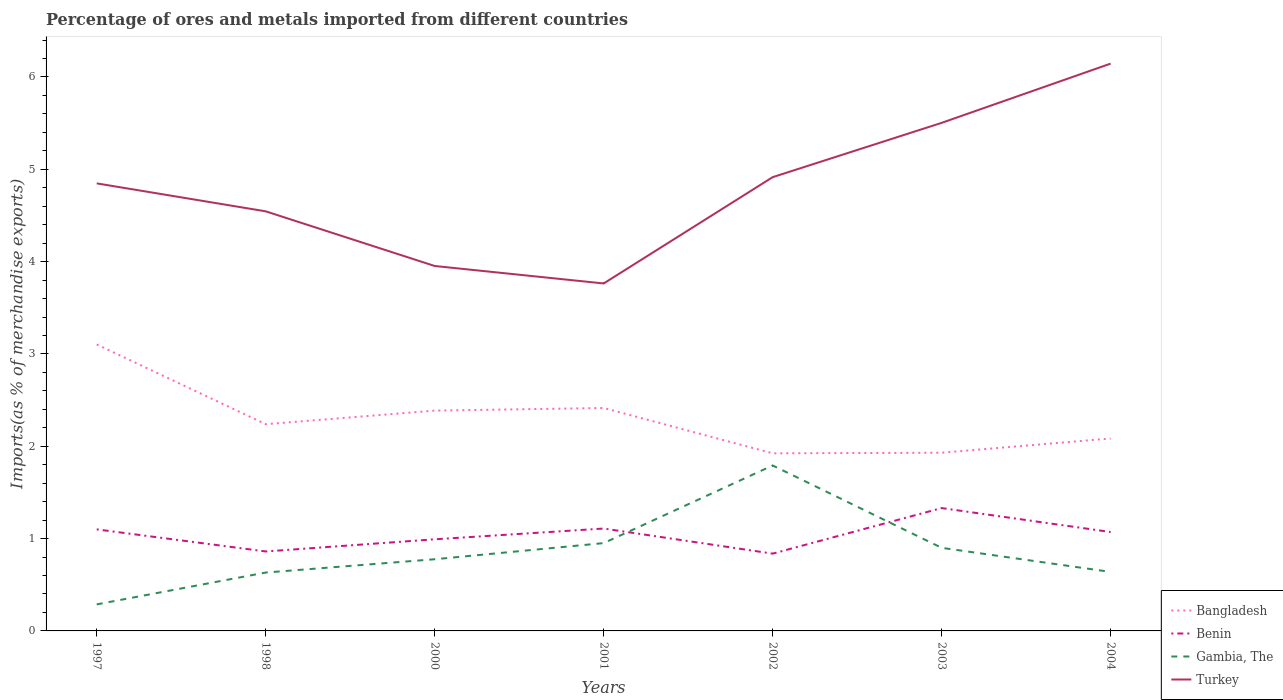Does the line corresponding to Bangladesh intersect with the line corresponding to Turkey?
Offer a terse response. No. Is the number of lines equal to the number of legend labels?
Your answer should be very brief. Yes. Across all years, what is the maximum percentage of imports to different countries in Benin?
Your response must be concise. 0.84. In which year was the percentage of imports to different countries in Gambia, The maximum?
Offer a terse response. 1997. What is the total percentage of imports to different countries in Turkey in the graph?
Make the answer very short. 0.89. What is the difference between the highest and the second highest percentage of imports to different countries in Benin?
Your response must be concise. 0.49. Does the graph contain grids?
Provide a succinct answer. No. How many legend labels are there?
Your response must be concise. 4. What is the title of the graph?
Provide a succinct answer. Percentage of ores and metals imported from different countries. Does "Kenya" appear as one of the legend labels in the graph?
Your answer should be very brief. No. What is the label or title of the Y-axis?
Your answer should be compact. Imports(as % of merchandise exports). What is the Imports(as % of merchandise exports) in Bangladesh in 1997?
Offer a very short reply. 3.1. What is the Imports(as % of merchandise exports) in Benin in 1997?
Offer a very short reply. 1.1. What is the Imports(as % of merchandise exports) in Gambia, The in 1997?
Offer a very short reply. 0.29. What is the Imports(as % of merchandise exports) of Turkey in 1997?
Give a very brief answer. 4.85. What is the Imports(as % of merchandise exports) of Bangladesh in 1998?
Your answer should be compact. 2.24. What is the Imports(as % of merchandise exports) of Benin in 1998?
Keep it short and to the point. 0.86. What is the Imports(as % of merchandise exports) in Gambia, The in 1998?
Give a very brief answer. 0.63. What is the Imports(as % of merchandise exports) of Turkey in 1998?
Your response must be concise. 4.54. What is the Imports(as % of merchandise exports) of Bangladesh in 2000?
Your answer should be compact. 2.39. What is the Imports(as % of merchandise exports) of Benin in 2000?
Make the answer very short. 0.99. What is the Imports(as % of merchandise exports) in Gambia, The in 2000?
Provide a succinct answer. 0.78. What is the Imports(as % of merchandise exports) in Turkey in 2000?
Your answer should be compact. 3.95. What is the Imports(as % of merchandise exports) of Bangladesh in 2001?
Provide a succinct answer. 2.41. What is the Imports(as % of merchandise exports) of Benin in 2001?
Make the answer very short. 1.11. What is the Imports(as % of merchandise exports) in Gambia, The in 2001?
Ensure brevity in your answer.  0.95. What is the Imports(as % of merchandise exports) of Turkey in 2001?
Offer a very short reply. 3.76. What is the Imports(as % of merchandise exports) in Bangladesh in 2002?
Keep it short and to the point. 1.92. What is the Imports(as % of merchandise exports) in Benin in 2002?
Provide a succinct answer. 0.84. What is the Imports(as % of merchandise exports) in Gambia, The in 2002?
Keep it short and to the point. 1.79. What is the Imports(as % of merchandise exports) in Turkey in 2002?
Give a very brief answer. 4.91. What is the Imports(as % of merchandise exports) in Bangladesh in 2003?
Offer a terse response. 1.93. What is the Imports(as % of merchandise exports) in Benin in 2003?
Keep it short and to the point. 1.33. What is the Imports(as % of merchandise exports) in Gambia, The in 2003?
Give a very brief answer. 0.9. What is the Imports(as % of merchandise exports) of Turkey in 2003?
Your answer should be compact. 5.5. What is the Imports(as % of merchandise exports) in Bangladesh in 2004?
Provide a succinct answer. 2.08. What is the Imports(as % of merchandise exports) in Benin in 2004?
Your answer should be compact. 1.07. What is the Imports(as % of merchandise exports) of Gambia, The in 2004?
Your answer should be compact. 0.64. What is the Imports(as % of merchandise exports) of Turkey in 2004?
Your answer should be very brief. 6.14. Across all years, what is the maximum Imports(as % of merchandise exports) of Bangladesh?
Provide a short and direct response. 3.1. Across all years, what is the maximum Imports(as % of merchandise exports) of Benin?
Your answer should be very brief. 1.33. Across all years, what is the maximum Imports(as % of merchandise exports) of Gambia, The?
Provide a short and direct response. 1.79. Across all years, what is the maximum Imports(as % of merchandise exports) in Turkey?
Keep it short and to the point. 6.14. Across all years, what is the minimum Imports(as % of merchandise exports) of Bangladesh?
Provide a succinct answer. 1.92. Across all years, what is the minimum Imports(as % of merchandise exports) in Benin?
Ensure brevity in your answer.  0.84. Across all years, what is the minimum Imports(as % of merchandise exports) of Gambia, The?
Provide a short and direct response. 0.29. Across all years, what is the minimum Imports(as % of merchandise exports) of Turkey?
Keep it short and to the point. 3.76. What is the total Imports(as % of merchandise exports) in Bangladesh in the graph?
Your answer should be compact. 16.08. What is the total Imports(as % of merchandise exports) of Benin in the graph?
Make the answer very short. 7.3. What is the total Imports(as % of merchandise exports) of Gambia, The in the graph?
Make the answer very short. 5.98. What is the total Imports(as % of merchandise exports) of Turkey in the graph?
Your answer should be very brief. 33.67. What is the difference between the Imports(as % of merchandise exports) in Bangladesh in 1997 and that in 1998?
Your response must be concise. 0.86. What is the difference between the Imports(as % of merchandise exports) of Benin in 1997 and that in 1998?
Give a very brief answer. 0.24. What is the difference between the Imports(as % of merchandise exports) in Gambia, The in 1997 and that in 1998?
Offer a terse response. -0.34. What is the difference between the Imports(as % of merchandise exports) of Turkey in 1997 and that in 1998?
Your response must be concise. 0.3. What is the difference between the Imports(as % of merchandise exports) of Bangladesh in 1997 and that in 2000?
Make the answer very short. 0.72. What is the difference between the Imports(as % of merchandise exports) of Benin in 1997 and that in 2000?
Your answer should be compact. 0.11. What is the difference between the Imports(as % of merchandise exports) in Gambia, The in 1997 and that in 2000?
Offer a very short reply. -0.49. What is the difference between the Imports(as % of merchandise exports) of Turkey in 1997 and that in 2000?
Make the answer very short. 0.89. What is the difference between the Imports(as % of merchandise exports) in Bangladesh in 1997 and that in 2001?
Your answer should be compact. 0.69. What is the difference between the Imports(as % of merchandise exports) in Benin in 1997 and that in 2001?
Provide a short and direct response. -0.01. What is the difference between the Imports(as % of merchandise exports) in Gambia, The in 1997 and that in 2001?
Ensure brevity in your answer.  -0.66. What is the difference between the Imports(as % of merchandise exports) in Turkey in 1997 and that in 2001?
Ensure brevity in your answer.  1.08. What is the difference between the Imports(as % of merchandise exports) of Bangladesh in 1997 and that in 2002?
Offer a very short reply. 1.18. What is the difference between the Imports(as % of merchandise exports) of Benin in 1997 and that in 2002?
Give a very brief answer. 0.26. What is the difference between the Imports(as % of merchandise exports) in Gambia, The in 1997 and that in 2002?
Your response must be concise. -1.5. What is the difference between the Imports(as % of merchandise exports) in Turkey in 1997 and that in 2002?
Offer a very short reply. -0.07. What is the difference between the Imports(as % of merchandise exports) in Bangladesh in 1997 and that in 2003?
Provide a short and direct response. 1.17. What is the difference between the Imports(as % of merchandise exports) of Benin in 1997 and that in 2003?
Ensure brevity in your answer.  -0.23. What is the difference between the Imports(as % of merchandise exports) of Gambia, The in 1997 and that in 2003?
Make the answer very short. -0.61. What is the difference between the Imports(as % of merchandise exports) of Turkey in 1997 and that in 2003?
Your response must be concise. -0.66. What is the difference between the Imports(as % of merchandise exports) of Bangladesh in 1997 and that in 2004?
Make the answer very short. 1.02. What is the difference between the Imports(as % of merchandise exports) of Benin in 1997 and that in 2004?
Offer a terse response. 0.03. What is the difference between the Imports(as % of merchandise exports) in Gambia, The in 1997 and that in 2004?
Ensure brevity in your answer.  -0.35. What is the difference between the Imports(as % of merchandise exports) of Turkey in 1997 and that in 2004?
Keep it short and to the point. -1.3. What is the difference between the Imports(as % of merchandise exports) in Bangladesh in 1998 and that in 2000?
Your answer should be very brief. -0.15. What is the difference between the Imports(as % of merchandise exports) of Benin in 1998 and that in 2000?
Provide a succinct answer. -0.13. What is the difference between the Imports(as % of merchandise exports) in Gambia, The in 1998 and that in 2000?
Offer a terse response. -0.14. What is the difference between the Imports(as % of merchandise exports) of Turkey in 1998 and that in 2000?
Your answer should be very brief. 0.59. What is the difference between the Imports(as % of merchandise exports) of Bangladesh in 1998 and that in 2001?
Provide a short and direct response. -0.18. What is the difference between the Imports(as % of merchandise exports) of Benin in 1998 and that in 2001?
Offer a terse response. -0.25. What is the difference between the Imports(as % of merchandise exports) in Gambia, The in 1998 and that in 2001?
Ensure brevity in your answer.  -0.32. What is the difference between the Imports(as % of merchandise exports) of Turkey in 1998 and that in 2001?
Ensure brevity in your answer.  0.78. What is the difference between the Imports(as % of merchandise exports) in Bangladesh in 1998 and that in 2002?
Your response must be concise. 0.32. What is the difference between the Imports(as % of merchandise exports) of Benin in 1998 and that in 2002?
Offer a very short reply. 0.02. What is the difference between the Imports(as % of merchandise exports) in Gambia, The in 1998 and that in 2002?
Make the answer very short. -1.16. What is the difference between the Imports(as % of merchandise exports) of Turkey in 1998 and that in 2002?
Your answer should be very brief. -0.37. What is the difference between the Imports(as % of merchandise exports) in Bangladesh in 1998 and that in 2003?
Give a very brief answer. 0.31. What is the difference between the Imports(as % of merchandise exports) of Benin in 1998 and that in 2003?
Offer a very short reply. -0.47. What is the difference between the Imports(as % of merchandise exports) of Gambia, The in 1998 and that in 2003?
Your response must be concise. -0.27. What is the difference between the Imports(as % of merchandise exports) of Turkey in 1998 and that in 2003?
Provide a short and direct response. -0.96. What is the difference between the Imports(as % of merchandise exports) of Bangladesh in 1998 and that in 2004?
Offer a very short reply. 0.15. What is the difference between the Imports(as % of merchandise exports) of Benin in 1998 and that in 2004?
Provide a short and direct response. -0.21. What is the difference between the Imports(as % of merchandise exports) of Gambia, The in 1998 and that in 2004?
Provide a succinct answer. -0.01. What is the difference between the Imports(as % of merchandise exports) of Turkey in 1998 and that in 2004?
Provide a succinct answer. -1.6. What is the difference between the Imports(as % of merchandise exports) of Bangladesh in 2000 and that in 2001?
Your response must be concise. -0.03. What is the difference between the Imports(as % of merchandise exports) in Benin in 2000 and that in 2001?
Your response must be concise. -0.12. What is the difference between the Imports(as % of merchandise exports) in Gambia, The in 2000 and that in 2001?
Offer a terse response. -0.17. What is the difference between the Imports(as % of merchandise exports) in Turkey in 2000 and that in 2001?
Your answer should be very brief. 0.19. What is the difference between the Imports(as % of merchandise exports) in Bangladesh in 2000 and that in 2002?
Ensure brevity in your answer.  0.46. What is the difference between the Imports(as % of merchandise exports) of Benin in 2000 and that in 2002?
Provide a succinct answer. 0.16. What is the difference between the Imports(as % of merchandise exports) of Gambia, The in 2000 and that in 2002?
Provide a succinct answer. -1.02. What is the difference between the Imports(as % of merchandise exports) of Turkey in 2000 and that in 2002?
Your response must be concise. -0.96. What is the difference between the Imports(as % of merchandise exports) of Bangladesh in 2000 and that in 2003?
Keep it short and to the point. 0.46. What is the difference between the Imports(as % of merchandise exports) in Benin in 2000 and that in 2003?
Your answer should be very brief. -0.34. What is the difference between the Imports(as % of merchandise exports) in Gambia, The in 2000 and that in 2003?
Make the answer very short. -0.12. What is the difference between the Imports(as % of merchandise exports) of Turkey in 2000 and that in 2003?
Provide a succinct answer. -1.55. What is the difference between the Imports(as % of merchandise exports) in Bangladesh in 2000 and that in 2004?
Your answer should be compact. 0.3. What is the difference between the Imports(as % of merchandise exports) of Benin in 2000 and that in 2004?
Give a very brief answer. -0.08. What is the difference between the Imports(as % of merchandise exports) of Gambia, The in 2000 and that in 2004?
Your answer should be compact. 0.14. What is the difference between the Imports(as % of merchandise exports) in Turkey in 2000 and that in 2004?
Your response must be concise. -2.19. What is the difference between the Imports(as % of merchandise exports) in Bangladesh in 2001 and that in 2002?
Provide a succinct answer. 0.49. What is the difference between the Imports(as % of merchandise exports) of Benin in 2001 and that in 2002?
Your response must be concise. 0.27. What is the difference between the Imports(as % of merchandise exports) in Gambia, The in 2001 and that in 2002?
Offer a very short reply. -0.84. What is the difference between the Imports(as % of merchandise exports) in Turkey in 2001 and that in 2002?
Keep it short and to the point. -1.15. What is the difference between the Imports(as % of merchandise exports) in Bangladesh in 2001 and that in 2003?
Your response must be concise. 0.48. What is the difference between the Imports(as % of merchandise exports) of Benin in 2001 and that in 2003?
Provide a short and direct response. -0.22. What is the difference between the Imports(as % of merchandise exports) of Gambia, The in 2001 and that in 2003?
Provide a short and direct response. 0.05. What is the difference between the Imports(as % of merchandise exports) of Turkey in 2001 and that in 2003?
Your response must be concise. -1.74. What is the difference between the Imports(as % of merchandise exports) of Bangladesh in 2001 and that in 2004?
Ensure brevity in your answer.  0.33. What is the difference between the Imports(as % of merchandise exports) in Benin in 2001 and that in 2004?
Provide a short and direct response. 0.04. What is the difference between the Imports(as % of merchandise exports) in Gambia, The in 2001 and that in 2004?
Ensure brevity in your answer.  0.31. What is the difference between the Imports(as % of merchandise exports) of Turkey in 2001 and that in 2004?
Your response must be concise. -2.38. What is the difference between the Imports(as % of merchandise exports) of Bangladesh in 2002 and that in 2003?
Your response must be concise. -0.01. What is the difference between the Imports(as % of merchandise exports) in Benin in 2002 and that in 2003?
Ensure brevity in your answer.  -0.49. What is the difference between the Imports(as % of merchandise exports) of Gambia, The in 2002 and that in 2003?
Your answer should be compact. 0.89. What is the difference between the Imports(as % of merchandise exports) of Turkey in 2002 and that in 2003?
Your answer should be compact. -0.59. What is the difference between the Imports(as % of merchandise exports) of Bangladesh in 2002 and that in 2004?
Provide a succinct answer. -0.16. What is the difference between the Imports(as % of merchandise exports) in Benin in 2002 and that in 2004?
Offer a very short reply. -0.23. What is the difference between the Imports(as % of merchandise exports) of Gambia, The in 2002 and that in 2004?
Make the answer very short. 1.15. What is the difference between the Imports(as % of merchandise exports) of Turkey in 2002 and that in 2004?
Your answer should be very brief. -1.23. What is the difference between the Imports(as % of merchandise exports) in Bangladesh in 2003 and that in 2004?
Offer a very short reply. -0.15. What is the difference between the Imports(as % of merchandise exports) in Benin in 2003 and that in 2004?
Make the answer very short. 0.26. What is the difference between the Imports(as % of merchandise exports) of Gambia, The in 2003 and that in 2004?
Offer a terse response. 0.26. What is the difference between the Imports(as % of merchandise exports) of Turkey in 2003 and that in 2004?
Offer a terse response. -0.64. What is the difference between the Imports(as % of merchandise exports) of Bangladesh in 1997 and the Imports(as % of merchandise exports) of Benin in 1998?
Provide a short and direct response. 2.24. What is the difference between the Imports(as % of merchandise exports) in Bangladesh in 1997 and the Imports(as % of merchandise exports) in Gambia, The in 1998?
Your response must be concise. 2.47. What is the difference between the Imports(as % of merchandise exports) of Bangladesh in 1997 and the Imports(as % of merchandise exports) of Turkey in 1998?
Your response must be concise. -1.44. What is the difference between the Imports(as % of merchandise exports) in Benin in 1997 and the Imports(as % of merchandise exports) in Gambia, The in 1998?
Provide a succinct answer. 0.47. What is the difference between the Imports(as % of merchandise exports) of Benin in 1997 and the Imports(as % of merchandise exports) of Turkey in 1998?
Offer a very short reply. -3.44. What is the difference between the Imports(as % of merchandise exports) in Gambia, The in 1997 and the Imports(as % of merchandise exports) in Turkey in 1998?
Your response must be concise. -4.26. What is the difference between the Imports(as % of merchandise exports) of Bangladesh in 1997 and the Imports(as % of merchandise exports) of Benin in 2000?
Give a very brief answer. 2.11. What is the difference between the Imports(as % of merchandise exports) in Bangladesh in 1997 and the Imports(as % of merchandise exports) in Gambia, The in 2000?
Keep it short and to the point. 2.33. What is the difference between the Imports(as % of merchandise exports) in Bangladesh in 1997 and the Imports(as % of merchandise exports) in Turkey in 2000?
Keep it short and to the point. -0.85. What is the difference between the Imports(as % of merchandise exports) in Benin in 1997 and the Imports(as % of merchandise exports) in Gambia, The in 2000?
Provide a succinct answer. 0.32. What is the difference between the Imports(as % of merchandise exports) of Benin in 1997 and the Imports(as % of merchandise exports) of Turkey in 2000?
Make the answer very short. -2.85. What is the difference between the Imports(as % of merchandise exports) of Gambia, The in 1997 and the Imports(as % of merchandise exports) of Turkey in 2000?
Give a very brief answer. -3.67. What is the difference between the Imports(as % of merchandise exports) of Bangladesh in 1997 and the Imports(as % of merchandise exports) of Benin in 2001?
Keep it short and to the point. 1.99. What is the difference between the Imports(as % of merchandise exports) in Bangladesh in 1997 and the Imports(as % of merchandise exports) in Gambia, The in 2001?
Provide a short and direct response. 2.15. What is the difference between the Imports(as % of merchandise exports) in Bangladesh in 1997 and the Imports(as % of merchandise exports) in Turkey in 2001?
Ensure brevity in your answer.  -0.66. What is the difference between the Imports(as % of merchandise exports) in Benin in 1997 and the Imports(as % of merchandise exports) in Gambia, The in 2001?
Your response must be concise. 0.15. What is the difference between the Imports(as % of merchandise exports) of Benin in 1997 and the Imports(as % of merchandise exports) of Turkey in 2001?
Provide a succinct answer. -2.66. What is the difference between the Imports(as % of merchandise exports) in Gambia, The in 1997 and the Imports(as % of merchandise exports) in Turkey in 2001?
Your answer should be compact. -3.48. What is the difference between the Imports(as % of merchandise exports) in Bangladesh in 1997 and the Imports(as % of merchandise exports) in Benin in 2002?
Offer a very short reply. 2.27. What is the difference between the Imports(as % of merchandise exports) of Bangladesh in 1997 and the Imports(as % of merchandise exports) of Gambia, The in 2002?
Your response must be concise. 1.31. What is the difference between the Imports(as % of merchandise exports) in Bangladesh in 1997 and the Imports(as % of merchandise exports) in Turkey in 2002?
Offer a very short reply. -1.81. What is the difference between the Imports(as % of merchandise exports) in Benin in 1997 and the Imports(as % of merchandise exports) in Gambia, The in 2002?
Make the answer very short. -0.69. What is the difference between the Imports(as % of merchandise exports) in Benin in 1997 and the Imports(as % of merchandise exports) in Turkey in 2002?
Provide a short and direct response. -3.81. What is the difference between the Imports(as % of merchandise exports) of Gambia, The in 1997 and the Imports(as % of merchandise exports) of Turkey in 2002?
Offer a very short reply. -4.63. What is the difference between the Imports(as % of merchandise exports) in Bangladesh in 1997 and the Imports(as % of merchandise exports) in Benin in 2003?
Ensure brevity in your answer.  1.77. What is the difference between the Imports(as % of merchandise exports) of Bangladesh in 1997 and the Imports(as % of merchandise exports) of Gambia, The in 2003?
Offer a very short reply. 2.2. What is the difference between the Imports(as % of merchandise exports) in Bangladesh in 1997 and the Imports(as % of merchandise exports) in Turkey in 2003?
Your answer should be compact. -2.4. What is the difference between the Imports(as % of merchandise exports) in Benin in 1997 and the Imports(as % of merchandise exports) in Gambia, The in 2003?
Your answer should be compact. 0.2. What is the difference between the Imports(as % of merchandise exports) in Benin in 1997 and the Imports(as % of merchandise exports) in Turkey in 2003?
Give a very brief answer. -4.4. What is the difference between the Imports(as % of merchandise exports) in Gambia, The in 1997 and the Imports(as % of merchandise exports) in Turkey in 2003?
Ensure brevity in your answer.  -5.22. What is the difference between the Imports(as % of merchandise exports) of Bangladesh in 1997 and the Imports(as % of merchandise exports) of Benin in 2004?
Offer a very short reply. 2.03. What is the difference between the Imports(as % of merchandise exports) in Bangladesh in 1997 and the Imports(as % of merchandise exports) in Gambia, The in 2004?
Provide a short and direct response. 2.46. What is the difference between the Imports(as % of merchandise exports) in Bangladesh in 1997 and the Imports(as % of merchandise exports) in Turkey in 2004?
Your answer should be very brief. -3.04. What is the difference between the Imports(as % of merchandise exports) in Benin in 1997 and the Imports(as % of merchandise exports) in Gambia, The in 2004?
Ensure brevity in your answer.  0.46. What is the difference between the Imports(as % of merchandise exports) of Benin in 1997 and the Imports(as % of merchandise exports) of Turkey in 2004?
Ensure brevity in your answer.  -5.04. What is the difference between the Imports(as % of merchandise exports) in Gambia, The in 1997 and the Imports(as % of merchandise exports) in Turkey in 2004?
Provide a short and direct response. -5.86. What is the difference between the Imports(as % of merchandise exports) of Bangladesh in 1998 and the Imports(as % of merchandise exports) of Benin in 2000?
Your answer should be compact. 1.25. What is the difference between the Imports(as % of merchandise exports) of Bangladesh in 1998 and the Imports(as % of merchandise exports) of Gambia, The in 2000?
Offer a very short reply. 1.46. What is the difference between the Imports(as % of merchandise exports) of Bangladesh in 1998 and the Imports(as % of merchandise exports) of Turkey in 2000?
Keep it short and to the point. -1.71. What is the difference between the Imports(as % of merchandise exports) in Benin in 1998 and the Imports(as % of merchandise exports) in Gambia, The in 2000?
Your response must be concise. 0.08. What is the difference between the Imports(as % of merchandise exports) in Benin in 1998 and the Imports(as % of merchandise exports) in Turkey in 2000?
Your answer should be very brief. -3.09. What is the difference between the Imports(as % of merchandise exports) of Gambia, The in 1998 and the Imports(as % of merchandise exports) of Turkey in 2000?
Make the answer very short. -3.32. What is the difference between the Imports(as % of merchandise exports) in Bangladesh in 1998 and the Imports(as % of merchandise exports) in Benin in 2001?
Make the answer very short. 1.13. What is the difference between the Imports(as % of merchandise exports) of Bangladesh in 1998 and the Imports(as % of merchandise exports) of Gambia, The in 2001?
Keep it short and to the point. 1.29. What is the difference between the Imports(as % of merchandise exports) in Bangladesh in 1998 and the Imports(as % of merchandise exports) in Turkey in 2001?
Provide a short and direct response. -1.52. What is the difference between the Imports(as % of merchandise exports) in Benin in 1998 and the Imports(as % of merchandise exports) in Gambia, The in 2001?
Offer a very short reply. -0.09. What is the difference between the Imports(as % of merchandise exports) in Benin in 1998 and the Imports(as % of merchandise exports) in Turkey in 2001?
Offer a terse response. -2.9. What is the difference between the Imports(as % of merchandise exports) of Gambia, The in 1998 and the Imports(as % of merchandise exports) of Turkey in 2001?
Offer a terse response. -3.13. What is the difference between the Imports(as % of merchandise exports) in Bangladesh in 1998 and the Imports(as % of merchandise exports) in Benin in 2002?
Ensure brevity in your answer.  1.4. What is the difference between the Imports(as % of merchandise exports) of Bangladesh in 1998 and the Imports(as % of merchandise exports) of Gambia, The in 2002?
Make the answer very short. 0.45. What is the difference between the Imports(as % of merchandise exports) in Bangladesh in 1998 and the Imports(as % of merchandise exports) in Turkey in 2002?
Offer a terse response. -2.68. What is the difference between the Imports(as % of merchandise exports) in Benin in 1998 and the Imports(as % of merchandise exports) in Gambia, The in 2002?
Ensure brevity in your answer.  -0.93. What is the difference between the Imports(as % of merchandise exports) in Benin in 1998 and the Imports(as % of merchandise exports) in Turkey in 2002?
Provide a succinct answer. -4.05. What is the difference between the Imports(as % of merchandise exports) of Gambia, The in 1998 and the Imports(as % of merchandise exports) of Turkey in 2002?
Give a very brief answer. -4.28. What is the difference between the Imports(as % of merchandise exports) of Bangladesh in 1998 and the Imports(as % of merchandise exports) of Benin in 2003?
Provide a succinct answer. 0.91. What is the difference between the Imports(as % of merchandise exports) in Bangladesh in 1998 and the Imports(as % of merchandise exports) in Gambia, The in 2003?
Provide a succinct answer. 1.34. What is the difference between the Imports(as % of merchandise exports) of Bangladesh in 1998 and the Imports(as % of merchandise exports) of Turkey in 2003?
Give a very brief answer. -3.26. What is the difference between the Imports(as % of merchandise exports) of Benin in 1998 and the Imports(as % of merchandise exports) of Gambia, The in 2003?
Your answer should be compact. -0.04. What is the difference between the Imports(as % of merchandise exports) in Benin in 1998 and the Imports(as % of merchandise exports) in Turkey in 2003?
Keep it short and to the point. -4.64. What is the difference between the Imports(as % of merchandise exports) in Gambia, The in 1998 and the Imports(as % of merchandise exports) in Turkey in 2003?
Provide a succinct answer. -4.87. What is the difference between the Imports(as % of merchandise exports) of Bangladesh in 1998 and the Imports(as % of merchandise exports) of Benin in 2004?
Make the answer very short. 1.17. What is the difference between the Imports(as % of merchandise exports) of Bangladesh in 1998 and the Imports(as % of merchandise exports) of Gambia, The in 2004?
Your answer should be compact. 1.6. What is the difference between the Imports(as % of merchandise exports) of Bangladesh in 1998 and the Imports(as % of merchandise exports) of Turkey in 2004?
Your answer should be very brief. -3.91. What is the difference between the Imports(as % of merchandise exports) of Benin in 1998 and the Imports(as % of merchandise exports) of Gambia, The in 2004?
Your answer should be compact. 0.22. What is the difference between the Imports(as % of merchandise exports) of Benin in 1998 and the Imports(as % of merchandise exports) of Turkey in 2004?
Your answer should be very brief. -5.28. What is the difference between the Imports(as % of merchandise exports) in Gambia, The in 1998 and the Imports(as % of merchandise exports) in Turkey in 2004?
Your response must be concise. -5.51. What is the difference between the Imports(as % of merchandise exports) in Bangladesh in 2000 and the Imports(as % of merchandise exports) in Benin in 2001?
Your response must be concise. 1.28. What is the difference between the Imports(as % of merchandise exports) in Bangladesh in 2000 and the Imports(as % of merchandise exports) in Gambia, The in 2001?
Make the answer very short. 1.44. What is the difference between the Imports(as % of merchandise exports) in Bangladesh in 2000 and the Imports(as % of merchandise exports) in Turkey in 2001?
Offer a terse response. -1.38. What is the difference between the Imports(as % of merchandise exports) of Benin in 2000 and the Imports(as % of merchandise exports) of Gambia, The in 2001?
Give a very brief answer. 0.04. What is the difference between the Imports(as % of merchandise exports) in Benin in 2000 and the Imports(as % of merchandise exports) in Turkey in 2001?
Provide a succinct answer. -2.77. What is the difference between the Imports(as % of merchandise exports) of Gambia, The in 2000 and the Imports(as % of merchandise exports) of Turkey in 2001?
Your answer should be compact. -2.99. What is the difference between the Imports(as % of merchandise exports) in Bangladesh in 2000 and the Imports(as % of merchandise exports) in Benin in 2002?
Your response must be concise. 1.55. What is the difference between the Imports(as % of merchandise exports) in Bangladesh in 2000 and the Imports(as % of merchandise exports) in Gambia, The in 2002?
Make the answer very short. 0.59. What is the difference between the Imports(as % of merchandise exports) of Bangladesh in 2000 and the Imports(as % of merchandise exports) of Turkey in 2002?
Provide a short and direct response. -2.53. What is the difference between the Imports(as % of merchandise exports) in Benin in 2000 and the Imports(as % of merchandise exports) in Gambia, The in 2002?
Offer a very short reply. -0.8. What is the difference between the Imports(as % of merchandise exports) in Benin in 2000 and the Imports(as % of merchandise exports) in Turkey in 2002?
Your answer should be very brief. -3.92. What is the difference between the Imports(as % of merchandise exports) of Gambia, The in 2000 and the Imports(as % of merchandise exports) of Turkey in 2002?
Your response must be concise. -4.14. What is the difference between the Imports(as % of merchandise exports) of Bangladesh in 2000 and the Imports(as % of merchandise exports) of Benin in 2003?
Offer a very short reply. 1.06. What is the difference between the Imports(as % of merchandise exports) of Bangladesh in 2000 and the Imports(as % of merchandise exports) of Gambia, The in 2003?
Your answer should be very brief. 1.49. What is the difference between the Imports(as % of merchandise exports) of Bangladesh in 2000 and the Imports(as % of merchandise exports) of Turkey in 2003?
Offer a very short reply. -3.12. What is the difference between the Imports(as % of merchandise exports) in Benin in 2000 and the Imports(as % of merchandise exports) in Gambia, The in 2003?
Offer a terse response. 0.09. What is the difference between the Imports(as % of merchandise exports) of Benin in 2000 and the Imports(as % of merchandise exports) of Turkey in 2003?
Offer a terse response. -4.51. What is the difference between the Imports(as % of merchandise exports) in Gambia, The in 2000 and the Imports(as % of merchandise exports) in Turkey in 2003?
Your answer should be very brief. -4.73. What is the difference between the Imports(as % of merchandise exports) in Bangladesh in 2000 and the Imports(as % of merchandise exports) in Benin in 2004?
Keep it short and to the point. 1.32. What is the difference between the Imports(as % of merchandise exports) in Bangladesh in 2000 and the Imports(as % of merchandise exports) in Gambia, The in 2004?
Offer a very short reply. 1.75. What is the difference between the Imports(as % of merchandise exports) in Bangladesh in 2000 and the Imports(as % of merchandise exports) in Turkey in 2004?
Give a very brief answer. -3.76. What is the difference between the Imports(as % of merchandise exports) of Benin in 2000 and the Imports(as % of merchandise exports) of Gambia, The in 2004?
Ensure brevity in your answer.  0.35. What is the difference between the Imports(as % of merchandise exports) in Benin in 2000 and the Imports(as % of merchandise exports) in Turkey in 2004?
Ensure brevity in your answer.  -5.15. What is the difference between the Imports(as % of merchandise exports) in Gambia, The in 2000 and the Imports(as % of merchandise exports) in Turkey in 2004?
Your answer should be very brief. -5.37. What is the difference between the Imports(as % of merchandise exports) in Bangladesh in 2001 and the Imports(as % of merchandise exports) in Benin in 2002?
Offer a terse response. 1.58. What is the difference between the Imports(as % of merchandise exports) of Bangladesh in 2001 and the Imports(as % of merchandise exports) of Gambia, The in 2002?
Offer a very short reply. 0.62. What is the difference between the Imports(as % of merchandise exports) in Bangladesh in 2001 and the Imports(as % of merchandise exports) in Turkey in 2002?
Keep it short and to the point. -2.5. What is the difference between the Imports(as % of merchandise exports) of Benin in 2001 and the Imports(as % of merchandise exports) of Gambia, The in 2002?
Ensure brevity in your answer.  -0.68. What is the difference between the Imports(as % of merchandise exports) of Benin in 2001 and the Imports(as % of merchandise exports) of Turkey in 2002?
Keep it short and to the point. -3.81. What is the difference between the Imports(as % of merchandise exports) of Gambia, The in 2001 and the Imports(as % of merchandise exports) of Turkey in 2002?
Give a very brief answer. -3.96. What is the difference between the Imports(as % of merchandise exports) in Bangladesh in 2001 and the Imports(as % of merchandise exports) in Benin in 2003?
Give a very brief answer. 1.08. What is the difference between the Imports(as % of merchandise exports) in Bangladesh in 2001 and the Imports(as % of merchandise exports) in Gambia, The in 2003?
Your response must be concise. 1.51. What is the difference between the Imports(as % of merchandise exports) of Bangladesh in 2001 and the Imports(as % of merchandise exports) of Turkey in 2003?
Keep it short and to the point. -3.09. What is the difference between the Imports(as % of merchandise exports) of Benin in 2001 and the Imports(as % of merchandise exports) of Gambia, The in 2003?
Ensure brevity in your answer.  0.21. What is the difference between the Imports(as % of merchandise exports) of Benin in 2001 and the Imports(as % of merchandise exports) of Turkey in 2003?
Your answer should be very brief. -4.39. What is the difference between the Imports(as % of merchandise exports) of Gambia, The in 2001 and the Imports(as % of merchandise exports) of Turkey in 2003?
Provide a succinct answer. -4.55. What is the difference between the Imports(as % of merchandise exports) in Bangladesh in 2001 and the Imports(as % of merchandise exports) in Benin in 2004?
Your answer should be compact. 1.34. What is the difference between the Imports(as % of merchandise exports) in Bangladesh in 2001 and the Imports(as % of merchandise exports) in Gambia, The in 2004?
Provide a short and direct response. 1.78. What is the difference between the Imports(as % of merchandise exports) of Bangladesh in 2001 and the Imports(as % of merchandise exports) of Turkey in 2004?
Your answer should be compact. -3.73. What is the difference between the Imports(as % of merchandise exports) in Benin in 2001 and the Imports(as % of merchandise exports) in Gambia, The in 2004?
Ensure brevity in your answer.  0.47. What is the difference between the Imports(as % of merchandise exports) of Benin in 2001 and the Imports(as % of merchandise exports) of Turkey in 2004?
Offer a terse response. -5.04. What is the difference between the Imports(as % of merchandise exports) in Gambia, The in 2001 and the Imports(as % of merchandise exports) in Turkey in 2004?
Offer a terse response. -5.19. What is the difference between the Imports(as % of merchandise exports) of Bangladesh in 2002 and the Imports(as % of merchandise exports) of Benin in 2003?
Give a very brief answer. 0.59. What is the difference between the Imports(as % of merchandise exports) in Bangladesh in 2002 and the Imports(as % of merchandise exports) in Gambia, The in 2003?
Provide a succinct answer. 1.02. What is the difference between the Imports(as % of merchandise exports) in Bangladesh in 2002 and the Imports(as % of merchandise exports) in Turkey in 2003?
Provide a succinct answer. -3.58. What is the difference between the Imports(as % of merchandise exports) in Benin in 2002 and the Imports(as % of merchandise exports) in Gambia, The in 2003?
Make the answer very short. -0.06. What is the difference between the Imports(as % of merchandise exports) of Benin in 2002 and the Imports(as % of merchandise exports) of Turkey in 2003?
Your answer should be very brief. -4.67. What is the difference between the Imports(as % of merchandise exports) of Gambia, The in 2002 and the Imports(as % of merchandise exports) of Turkey in 2003?
Offer a terse response. -3.71. What is the difference between the Imports(as % of merchandise exports) in Bangladesh in 2002 and the Imports(as % of merchandise exports) in Benin in 2004?
Ensure brevity in your answer.  0.85. What is the difference between the Imports(as % of merchandise exports) of Bangladesh in 2002 and the Imports(as % of merchandise exports) of Gambia, The in 2004?
Ensure brevity in your answer.  1.28. What is the difference between the Imports(as % of merchandise exports) in Bangladesh in 2002 and the Imports(as % of merchandise exports) in Turkey in 2004?
Ensure brevity in your answer.  -4.22. What is the difference between the Imports(as % of merchandise exports) in Benin in 2002 and the Imports(as % of merchandise exports) in Gambia, The in 2004?
Provide a short and direct response. 0.2. What is the difference between the Imports(as % of merchandise exports) in Benin in 2002 and the Imports(as % of merchandise exports) in Turkey in 2004?
Your response must be concise. -5.31. What is the difference between the Imports(as % of merchandise exports) of Gambia, The in 2002 and the Imports(as % of merchandise exports) of Turkey in 2004?
Your answer should be very brief. -4.35. What is the difference between the Imports(as % of merchandise exports) in Bangladesh in 2003 and the Imports(as % of merchandise exports) in Benin in 2004?
Your answer should be compact. 0.86. What is the difference between the Imports(as % of merchandise exports) in Bangladesh in 2003 and the Imports(as % of merchandise exports) in Gambia, The in 2004?
Ensure brevity in your answer.  1.29. What is the difference between the Imports(as % of merchandise exports) of Bangladesh in 2003 and the Imports(as % of merchandise exports) of Turkey in 2004?
Provide a succinct answer. -4.21. What is the difference between the Imports(as % of merchandise exports) in Benin in 2003 and the Imports(as % of merchandise exports) in Gambia, The in 2004?
Provide a succinct answer. 0.69. What is the difference between the Imports(as % of merchandise exports) of Benin in 2003 and the Imports(as % of merchandise exports) of Turkey in 2004?
Make the answer very short. -4.81. What is the difference between the Imports(as % of merchandise exports) of Gambia, The in 2003 and the Imports(as % of merchandise exports) of Turkey in 2004?
Your answer should be compact. -5.24. What is the average Imports(as % of merchandise exports) in Bangladesh per year?
Offer a terse response. 2.3. What is the average Imports(as % of merchandise exports) of Benin per year?
Keep it short and to the point. 1.04. What is the average Imports(as % of merchandise exports) of Gambia, The per year?
Your response must be concise. 0.85. What is the average Imports(as % of merchandise exports) of Turkey per year?
Provide a succinct answer. 4.81. In the year 1997, what is the difference between the Imports(as % of merchandise exports) in Bangladesh and Imports(as % of merchandise exports) in Benin?
Your response must be concise. 2. In the year 1997, what is the difference between the Imports(as % of merchandise exports) of Bangladesh and Imports(as % of merchandise exports) of Gambia, The?
Provide a succinct answer. 2.82. In the year 1997, what is the difference between the Imports(as % of merchandise exports) of Bangladesh and Imports(as % of merchandise exports) of Turkey?
Provide a short and direct response. -1.74. In the year 1997, what is the difference between the Imports(as % of merchandise exports) in Benin and Imports(as % of merchandise exports) in Gambia, The?
Offer a terse response. 0.81. In the year 1997, what is the difference between the Imports(as % of merchandise exports) in Benin and Imports(as % of merchandise exports) in Turkey?
Give a very brief answer. -3.75. In the year 1997, what is the difference between the Imports(as % of merchandise exports) of Gambia, The and Imports(as % of merchandise exports) of Turkey?
Provide a succinct answer. -4.56. In the year 1998, what is the difference between the Imports(as % of merchandise exports) of Bangladesh and Imports(as % of merchandise exports) of Benin?
Your response must be concise. 1.38. In the year 1998, what is the difference between the Imports(as % of merchandise exports) in Bangladesh and Imports(as % of merchandise exports) in Gambia, The?
Your answer should be very brief. 1.61. In the year 1998, what is the difference between the Imports(as % of merchandise exports) of Bangladesh and Imports(as % of merchandise exports) of Turkey?
Make the answer very short. -2.31. In the year 1998, what is the difference between the Imports(as % of merchandise exports) of Benin and Imports(as % of merchandise exports) of Gambia, The?
Keep it short and to the point. 0.23. In the year 1998, what is the difference between the Imports(as % of merchandise exports) of Benin and Imports(as % of merchandise exports) of Turkey?
Keep it short and to the point. -3.68. In the year 1998, what is the difference between the Imports(as % of merchandise exports) in Gambia, The and Imports(as % of merchandise exports) in Turkey?
Offer a very short reply. -3.91. In the year 2000, what is the difference between the Imports(as % of merchandise exports) of Bangladesh and Imports(as % of merchandise exports) of Benin?
Offer a very short reply. 1.39. In the year 2000, what is the difference between the Imports(as % of merchandise exports) of Bangladesh and Imports(as % of merchandise exports) of Gambia, The?
Your answer should be compact. 1.61. In the year 2000, what is the difference between the Imports(as % of merchandise exports) in Bangladesh and Imports(as % of merchandise exports) in Turkey?
Offer a very short reply. -1.57. In the year 2000, what is the difference between the Imports(as % of merchandise exports) of Benin and Imports(as % of merchandise exports) of Gambia, The?
Your response must be concise. 0.22. In the year 2000, what is the difference between the Imports(as % of merchandise exports) in Benin and Imports(as % of merchandise exports) in Turkey?
Provide a succinct answer. -2.96. In the year 2000, what is the difference between the Imports(as % of merchandise exports) of Gambia, The and Imports(as % of merchandise exports) of Turkey?
Make the answer very short. -3.18. In the year 2001, what is the difference between the Imports(as % of merchandise exports) in Bangladesh and Imports(as % of merchandise exports) in Benin?
Provide a succinct answer. 1.31. In the year 2001, what is the difference between the Imports(as % of merchandise exports) of Bangladesh and Imports(as % of merchandise exports) of Gambia, The?
Offer a very short reply. 1.46. In the year 2001, what is the difference between the Imports(as % of merchandise exports) in Bangladesh and Imports(as % of merchandise exports) in Turkey?
Your answer should be very brief. -1.35. In the year 2001, what is the difference between the Imports(as % of merchandise exports) in Benin and Imports(as % of merchandise exports) in Gambia, The?
Provide a short and direct response. 0.16. In the year 2001, what is the difference between the Imports(as % of merchandise exports) of Benin and Imports(as % of merchandise exports) of Turkey?
Offer a very short reply. -2.65. In the year 2001, what is the difference between the Imports(as % of merchandise exports) of Gambia, The and Imports(as % of merchandise exports) of Turkey?
Offer a very short reply. -2.81. In the year 2002, what is the difference between the Imports(as % of merchandise exports) of Bangladesh and Imports(as % of merchandise exports) of Benin?
Provide a short and direct response. 1.09. In the year 2002, what is the difference between the Imports(as % of merchandise exports) of Bangladesh and Imports(as % of merchandise exports) of Gambia, The?
Your answer should be very brief. 0.13. In the year 2002, what is the difference between the Imports(as % of merchandise exports) of Bangladesh and Imports(as % of merchandise exports) of Turkey?
Offer a terse response. -2.99. In the year 2002, what is the difference between the Imports(as % of merchandise exports) of Benin and Imports(as % of merchandise exports) of Gambia, The?
Provide a succinct answer. -0.95. In the year 2002, what is the difference between the Imports(as % of merchandise exports) of Benin and Imports(as % of merchandise exports) of Turkey?
Provide a succinct answer. -4.08. In the year 2002, what is the difference between the Imports(as % of merchandise exports) in Gambia, The and Imports(as % of merchandise exports) in Turkey?
Your response must be concise. -3.12. In the year 2003, what is the difference between the Imports(as % of merchandise exports) in Bangladesh and Imports(as % of merchandise exports) in Benin?
Ensure brevity in your answer.  0.6. In the year 2003, what is the difference between the Imports(as % of merchandise exports) in Bangladesh and Imports(as % of merchandise exports) in Gambia, The?
Offer a very short reply. 1.03. In the year 2003, what is the difference between the Imports(as % of merchandise exports) of Bangladesh and Imports(as % of merchandise exports) of Turkey?
Give a very brief answer. -3.57. In the year 2003, what is the difference between the Imports(as % of merchandise exports) of Benin and Imports(as % of merchandise exports) of Gambia, The?
Provide a succinct answer. 0.43. In the year 2003, what is the difference between the Imports(as % of merchandise exports) in Benin and Imports(as % of merchandise exports) in Turkey?
Your answer should be compact. -4.17. In the year 2003, what is the difference between the Imports(as % of merchandise exports) in Gambia, The and Imports(as % of merchandise exports) in Turkey?
Provide a short and direct response. -4.6. In the year 2004, what is the difference between the Imports(as % of merchandise exports) of Bangladesh and Imports(as % of merchandise exports) of Benin?
Ensure brevity in your answer.  1.01. In the year 2004, what is the difference between the Imports(as % of merchandise exports) in Bangladesh and Imports(as % of merchandise exports) in Gambia, The?
Ensure brevity in your answer.  1.45. In the year 2004, what is the difference between the Imports(as % of merchandise exports) of Bangladesh and Imports(as % of merchandise exports) of Turkey?
Make the answer very short. -4.06. In the year 2004, what is the difference between the Imports(as % of merchandise exports) in Benin and Imports(as % of merchandise exports) in Gambia, The?
Keep it short and to the point. 0.43. In the year 2004, what is the difference between the Imports(as % of merchandise exports) of Benin and Imports(as % of merchandise exports) of Turkey?
Offer a terse response. -5.07. In the year 2004, what is the difference between the Imports(as % of merchandise exports) of Gambia, The and Imports(as % of merchandise exports) of Turkey?
Provide a succinct answer. -5.51. What is the ratio of the Imports(as % of merchandise exports) of Bangladesh in 1997 to that in 1998?
Your answer should be very brief. 1.39. What is the ratio of the Imports(as % of merchandise exports) of Benin in 1997 to that in 1998?
Make the answer very short. 1.28. What is the ratio of the Imports(as % of merchandise exports) in Gambia, The in 1997 to that in 1998?
Offer a very short reply. 0.45. What is the ratio of the Imports(as % of merchandise exports) of Turkey in 1997 to that in 1998?
Provide a succinct answer. 1.07. What is the ratio of the Imports(as % of merchandise exports) of Bangladesh in 1997 to that in 2000?
Provide a succinct answer. 1.3. What is the ratio of the Imports(as % of merchandise exports) of Benin in 1997 to that in 2000?
Your answer should be compact. 1.11. What is the ratio of the Imports(as % of merchandise exports) in Gambia, The in 1997 to that in 2000?
Keep it short and to the point. 0.37. What is the ratio of the Imports(as % of merchandise exports) of Turkey in 1997 to that in 2000?
Ensure brevity in your answer.  1.23. What is the ratio of the Imports(as % of merchandise exports) of Bangladesh in 1997 to that in 2001?
Give a very brief answer. 1.28. What is the ratio of the Imports(as % of merchandise exports) of Gambia, The in 1997 to that in 2001?
Offer a terse response. 0.3. What is the ratio of the Imports(as % of merchandise exports) in Turkey in 1997 to that in 2001?
Provide a succinct answer. 1.29. What is the ratio of the Imports(as % of merchandise exports) in Bangladesh in 1997 to that in 2002?
Your answer should be compact. 1.61. What is the ratio of the Imports(as % of merchandise exports) in Benin in 1997 to that in 2002?
Your response must be concise. 1.31. What is the ratio of the Imports(as % of merchandise exports) of Gambia, The in 1997 to that in 2002?
Make the answer very short. 0.16. What is the ratio of the Imports(as % of merchandise exports) of Turkey in 1997 to that in 2002?
Make the answer very short. 0.99. What is the ratio of the Imports(as % of merchandise exports) of Bangladesh in 1997 to that in 2003?
Your response must be concise. 1.61. What is the ratio of the Imports(as % of merchandise exports) of Benin in 1997 to that in 2003?
Offer a terse response. 0.83. What is the ratio of the Imports(as % of merchandise exports) in Gambia, The in 1997 to that in 2003?
Offer a very short reply. 0.32. What is the ratio of the Imports(as % of merchandise exports) of Turkey in 1997 to that in 2003?
Keep it short and to the point. 0.88. What is the ratio of the Imports(as % of merchandise exports) of Bangladesh in 1997 to that in 2004?
Your response must be concise. 1.49. What is the ratio of the Imports(as % of merchandise exports) of Benin in 1997 to that in 2004?
Your response must be concise. 1.03. What is the ratio of the Imports(as % of merchandise exports) in Gambia, The in 1997 to that in 2004?
Ensure brevity in your answer.  0.45. What is the ratio of the Imports(as % of merchandise exports) in Turkey in 1997 to that in 2004?
Provide a short and direct response. 0.79. What is the ratio of the Imports(as % of merchandise exports) in Bangladesh in 1998 to that in 2000?
Offer a very short reply. 0.94. What is the ratio of the Imports(as % of merchandise exports) in Benin in 1998 to that in 2000?
Your answer should be compact. 0.87. What is the ratio of the Imports(as % of merchandise exports) of Gambia, The in 1998 to that in 2000?
Give a very brief answer. 0.81. What is the ratio of the Imports(as % of merchandise exports) of Turkey in 1998 to that in 2000?
Ensure brevity in your answer.  1.15. What is the ratio of the Imports(as % of merchandise exports) of Bangladesh in 1998 to that in 2001?
Ensure brevity in your answer.  0.93. What is the ratio of the Imports(as % of merchandise exports) of Benin in 1998 to that in 2001?
Make the answer very short. 0.78. What is the ratio of the Imports(as % of merchandise exports) in Gambia, The in 1998 to that in 2001?
Provide a short and direct response. 0.66. What is the ratio of the Imports(as % of merchandise exports) in Turkey in 1998 to that in 2001?
Keep it short and to the point. 1.21. What is the ratio of the Imports(as % of merchandise exports) in Bangladesh in 1998 to that in 2002?
Keep it short and to the point. 1.16. What is the ratio of the Imports(as % of merchandise exports) in Benin in 1998 to that in 2002?
Provide a succinct answer. 1.03. What is the ratio of the Imports(as % of merchandise exports) of Gambia, The in 1998 to that in 2002?
Provide a succinct answer. 0.35. What is the ratio of the Imports(as % of merchandise exports) in Turkey in 1998 to that in 2002?
Provide a succinct answer. 0.92. What is the ratio of the Imports(as % of merchandise exports) of Bangladesh in 1998 to that in 2003?
Give a very brief answer. 1.16. What is the ratio of the Imports(as % of merchandise exports) in Benin in 1998 to that in 2003?
Keep it short and to the point. 0.65. What is the ratio of the Imports(as % of merchandise exports) of Gambia, The in 1998 to that in 2003?
Keep it short and to the point. 0.7. What is the ratio of the Imports(as % of merchandise exports) in Turkey in 1998 to that in 2003?
Offer a terse response. 0.83. What is the ratio of the Imports(as % of merchandise exports) of Bangladesh in 1998 to that in 2004?
Make the answer very short. 1.07. What is the ratio of the Imports(as % of merchandise exports) in Benin in 1998 to that in 2004?
Your response must be concise. 0.8. What is the ratio of the Imports(as % of merchandise exports) in Turkey in 1998 to that in 2004?
Provide a short and direct response. 0.74. What is the ratio of the Imports(as % of merchandise exports) in Bangladesh in 2000 to that in 2001?
Make the answer very short. 0.99. What is the ratio of the Imports(as % of merchandise exports) in Benin in 2000 to that in 2001?
Your response must be concise. 0.89. What is the ratio of the Imports(as % of merchandise exports) in Gambia, The in 2000 to that in 2001?
Keep it short and to the point. 0.82. What is the ratio of the Imports(as % of merchandise exports) of Turkey in 2000 to that in 2001?
Make the answer very short. 1.05. What is the ratio of the Imports(as % of merchandise exports) of Bangladesh in 2000 to that in 2002?
Your response must be concise. 1.24. What is the ratio of the Imports(as % of merchandise exports) of Benin in 2000 to that in 2002?
Your answer should be very brief. 1.19. What is the ratio of the Imports(as % of merchandise exports) of Gambia, The in 2000 to that in 2002?
Ensure brevity in your answer.  0.43. What is the ratio of the Imports(as % of merchandise exports) in Turkey in 2000 to that in 2002?
Offer a very short reply. 0.8. What is the ratio of the Imports(as % of merchandise exports) of Bangladesh in 2000 to that in 2003?
Make the answer very short. 1.24. What is the ratio of the Imports(as % of merchandise exports) in Benin in 2000 to that in 2003?
Ensure brevity in your answer.  0.75. What is the ratio of the Imports(as % of merchandise exports) in Gambia, The in 2000 to that in 2003?
Your answer should be compact. 0.86. What is the ratio of the Imports(as % of merchandise exports) in Turkey in 2000 to that in 2003?
Keep it short and to the point. 0.72. What is the ratio of the Imports(as % of merchandise exports) of Bangladesh in 2000 to that in 2004?
Ensure brevity in your answer.  1.14. What is the ratio of the Imports(as % of merchandise exports) of Benin in 2000 to that in 2004?
Keep it short and to the point. 0.93. What is the ratio of the Imports(as % of merchandise exports) of Gambia, The in 2000 to that in 2004?
Your response must be concise. 1.21. What is the ratio of the Imports(as % of merchandise exports) of Turkey in 2000 to that in 2004?
Give a very brief answer. 0.64. What is the ratio of the Imports(as % of merchandise exports) in Bangladesh in 2001 to that in 2002?
Provide a short and direct response. 1.26. What is the ratio of the Imports(as % of merchandise exports) in Benin in 2001 to that in 2002?
Make the answer very short. 1.32. What is the ratio of the Imports(as % of merchandise exports) of Gambia, The in 2001 to that in 2002?
Offer a very short reply. 0.53. What is the ratio of the Imports(as % of merchandise exports) in Turkey in 2001 to that in 2002?
Give a very brief answer. 0.77. What is the ratio of the Imports(as % of merchandise exports) in Bangladesh in 2001 to that in 2003?
Offer a terse response. 1.25. What is the ratio of the Imports(as % of merchandise exports) of Benin in 2001 to that in 2003?
Give a very brief answer. 0.83. What is the ratio of the Imports(as % of merchandise exports) of Gambia, The in 2001 to that in 2003?
Ensure brevity in your answer.  1.06. What is the ratio of the Imports(as % of merchandise exports) in Turkey in 2001 to that in 2003?
Offer a very short reply. 0.68. What is the ratio of the Imports(as % of merchandise exports) in Bangladesh in 2001 to that in 2004?
Your response must be concise. 1.16. What is the ratio of the Imports(as % of merchandise exports) of Benin in 2001 to that in 2004?
Offer a terse response. 1.04. What is the ratio of the Imports(as % of merchandise exports) in Gambia, The in 2001 to that in 2004?
Your answer should be compact. 1.49. What is the ratio of the Imports(as % of merchandise exports) in Turkey in 2001 to that in 2004?
Offer a terse response. 0.61. What is the ratio of the Imports(as % of merchandise exports) of Bangladesh in 2002 to that in 2003?
Provide a short and direct response. 1. What is the ratio of the Imports(as % of merchandise exports) in Benin in 2002 to that in 2003?
Provide a short and direct response. 0.63. What is the ratio of the Imports(as % of merchandise exports) in Gambia, The in 2002 to that in 2003?
Your answer should be very brief. 1.99. What is the ratio of the Imports(as % of merchandise exports) in Turkey in 2002 to that in 2003?
Make the answer very short. 0.89. What is the ratio of the Imports(as % of merchandise exports) in Bangladesh in 2002 to that in 2004?
Your response must be concise. 0.92. What is the ratio of the Imports(as % of merchandise exports) of Benin in 2002 to that in 2004?
Offer a terse response. 0.78. What is the ratio of the Imports(as % of merchandise exports) of Gambia, The in 2002 to that in 2004?
Give a very brief answer. 2.8. What is the ratio of the Imports(as % of merchandise exports) of Turkey in 2002 to that in 2004?
Provide a succinct answer. 0.8. What is the ratio of the Imports(as % of merchandise exports) of Bangladesh in 2003 to that in 2004?
Your answer should be compact. 0.93. What is the ratio of the Imports(as % of merchandise exports) of Benin in 2003 to that in 2004?
Provide a succinct answer. 1.24. What is the ratio of the Imports(as % of merchandise exports) of Gambia, The in 2003 to that in 2004?
Keep it short and to the point. 1.41. What is the ratio of the Imports(as % of merchandise exports) in Turkey in 2003 to that in 2004?
Give a very brief answer. 0.9. What is the difference between the highest and the second highest Imports(as % of merchandise exports) in Bangladesh?
Your answer should be very brief. 0.69. What is the difference between the highest and the second highest Imports(as % of merchandise exports) in Benin?
Ensure brevity in your answer.  0.22. What is the difference between the highest and the second highest Imports(as % of merchandise exports) in Gambia, The?
Your response must be concise. 0.84. What is the difference between the highest and the second highest Imports(as % of merchandise exports) of Turkey?
Your answer should be compact. 0.64. What is the difference between the highest and the lowest Imports(as % of merchandise exports) in Bangladesh?
Make the answer very short. 1.18. What is the difference between the highest and the lowest Imports(as % of merchandise exports) of Benin?
Your response must be concise. 0.49. What is the difference between the highest and the lowest Imports(as % of merchandise exports) of Gambia, The?
Make the answer very short. 1.5. What is the difference between the highest and the lowest Imports(as % of merchandise exports) in Turkey?
Provide a succinct answer. 2.38. 